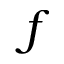Convert formula to latex. <formula><loc_0><loc_0><loc_500><loc_500>f</formula> 